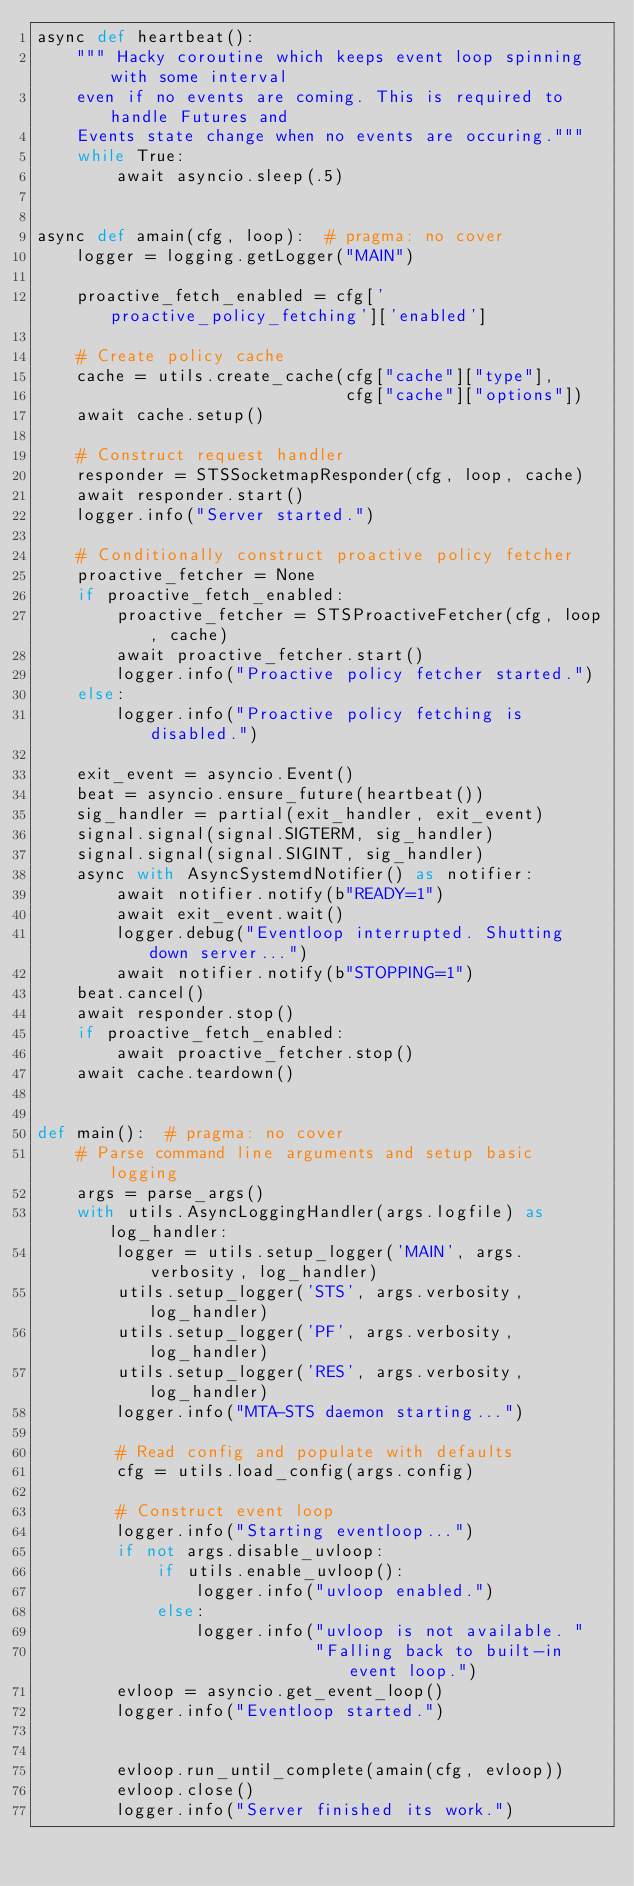Convert code to text. <code><loc_0><loc_0><loc_500><loc_500><_Python_>async def heartbeat():
    """ Hacky coroutine which keeps event loop spinning with some interval
    even if no events are coming. This is required to handle Futures and
    Events state change when no events are occuring."""
    while True:
        await asyncio.sleep(.5)


async def amain(cfg, loop):  # pragma: no cover
    logger = logging.getLogger("MAIN")

    proactive_fetch_enabled = cfg['proactive_policy_fetching']['enabled']

    # Create policy cache
    cache = utils.create_cache(cfg["cache"]["type"],
                               cfg["cache"]["options"])
    await cache.setup()

    # Construct request handler
    responder = STSSocketmapResponder(cfg, loop, cache)
    await responder.start()
    logger.info("Server started.")

    # Conditionally construct proactive policy fetcher
    proactive_fetcher = None
    if proactive_fetch_enabled:
        proactive_fetcher = STSProactiveFetcher(cfg, loop, cache)
        await proactive_fetcher.start()
        logger.info("Proactive policy fetcher started.")
    else:
        logger.info("Proactive policy fetching is disabled.")

    exit_event = asyncio.Event()
    beat = asyncio.ensure_future(heartbeat())
    sig_handler = partial(exit_handler, exit_event)
    signal.signal(signal.SIGTERM, sig_handler)
    signal.signal(signal.SIGINT, sig_handler)
    async with AsyncSystemdNotifier() as notifier:
        await notifier.notify(b"READY=1")
        await exit_event.wait()
        logger.debug("Eventloop interrupted. Shutting down server...")
        await notifier.notify(b"STOPPING=1")
    beat.cancel()
    await responder.stop()
    if proactive_fetch_enabled:
        await proactive_fetcher.stop()
    await cache.teardown()


def main():  # pragma: no cover
    # Parse command line arguments and setup basic logging
    args = parse_args()
    with utils.AsyncLoggingHandler(args.logfile) as log_handler:
        logger = utils.setup_logger('MAIN', args.verbosity, log_handler)
        utils.setup_logger('STS', args.verbosity, log_handler)
        utils.setup_logger('PF', args.verbosity, log_handler)
        utils.setup_logger('RES', args.verbosity, log_handler)
        logger.info("MTA-STS daemon starting...")

        # Read config and populate with defaults
        cfg = utils.load_config(args.config)

        # Construct event loop
        logger.info("Starting eventloop...")
        if not args.disable_uvloop:
            if utils.enable_uvloop():
                logger.info("uvloop enabled.")
            else:
                logger.info("uvloop is not available. "
                            "Falling back to built-in event loop.")
        evloop = asyncio.get_event_loop()
        logger.info("Eventloop started.")


        evloop.run_until_complete(amain(cfg, evloop))
        evloop.close()
        logger.info("Server finished its work.")
</code> 